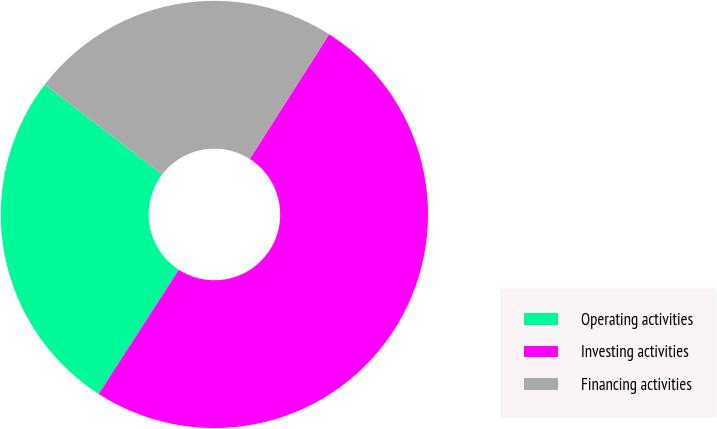Convert chart. <chart><loc_0><loc_0><loc_500><loc_500><pie_chart><fcel>Operating activities<fcel>Investing activities<fcel>Financing activities<nl><fcel>26.28%<fcel>50.09%<fcel>23.63%<nl></chart> 